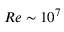Convert formula to latex. <formula><loc_0><loc_0><loc_500><loc_500>R e \sim 1 0 ^ { 7 }</formula> 